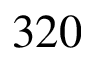<formula> <loc_0><loc_0><loc_500><loc_500>3 2 0</formula> 